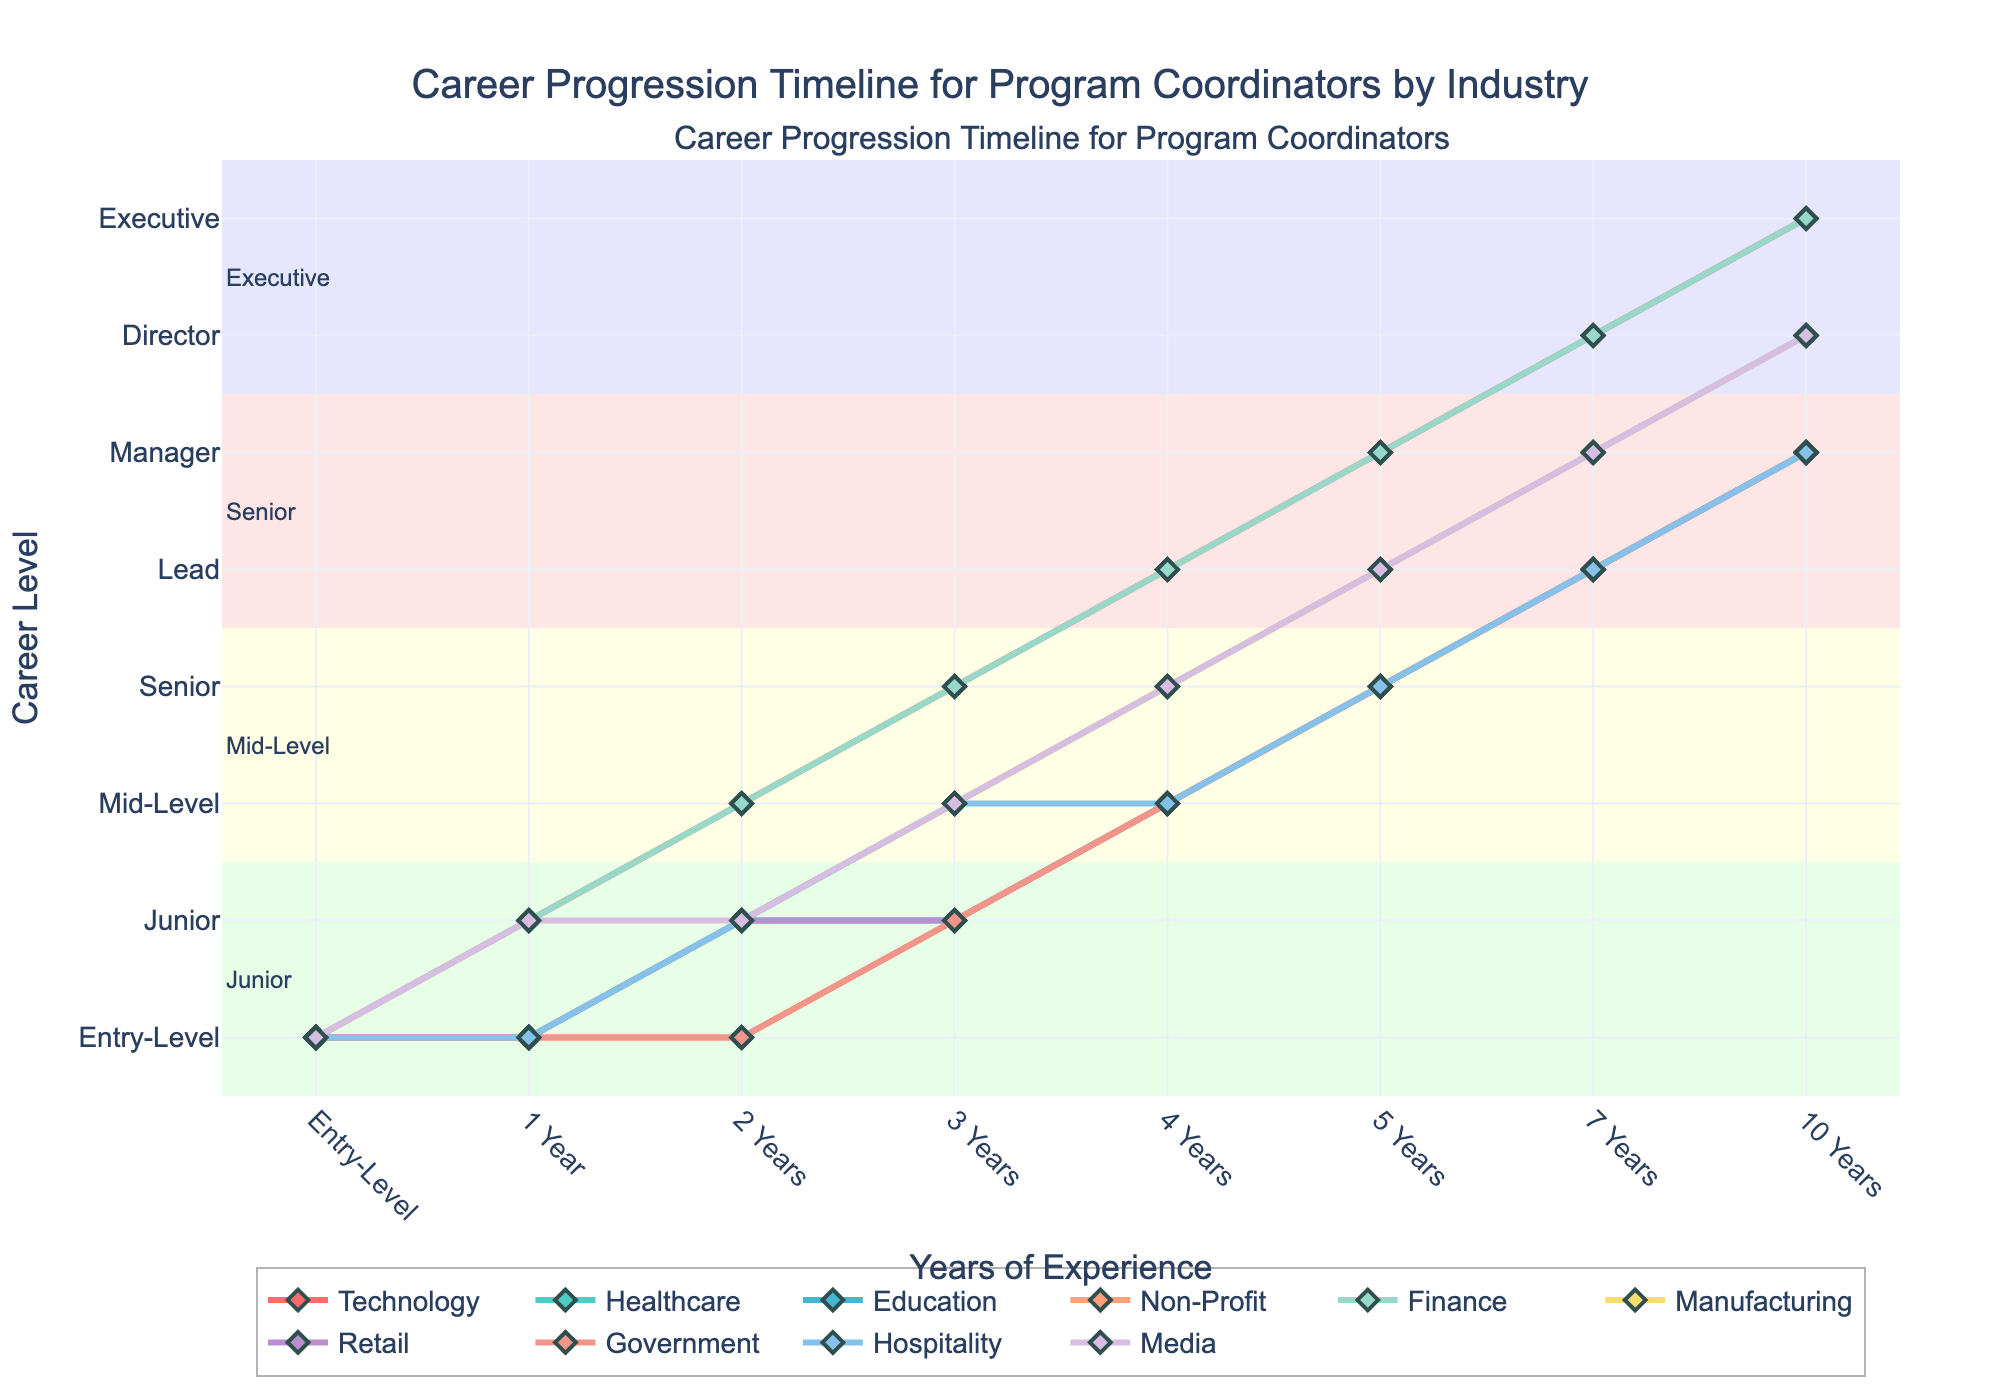What is the career level of a program coordinator in the Technology industry after 5 years? Look at the line representing the Technology industry and find the data point at the 5-year mark. The y-axis indicates the career level, which is 6, corresponding to 'Manager'.
Answer: Manager Which industry shows the fastest career progression in the first 2 years? Compare the slopes of the lines for different industries from 0 to 2 years. The Technology and Finance industries have the steepest slopes, both reaching level 3 in 2 years. Other industries reach lower career levels.
Answer: Technology, Finance After 4 years, which industry has the lowest career level for a program coordinator? Identify the 4-year mark across all lines and check the y-values. The Non-Profit, Education, and Government industries all reach level 3, which is the lowest at that time.
Answer: Non-Profit, Education, Government What is the average career level of a program coordinator in the Retail industry over the 10-year period? Sum up the career levels from 0 to 10 years for the Retail industry (1+1+2+2+3+4+5+6) = 24, then divide by the number of years (10) for the average (24/10).
Answer: 2.4 Compare the career progression of the Healthcare and Manufacturing industries from 1 year to 3 years. Which one progresses faster? Check the y-values at the 1-year to 3-year marks for both industries. Healthcare moves from level 1 to 3, while Manufacturing moves from level 1 to 3. Both progress at the same rate.
Answer: Same rate Which industry has the highest career level at the 7-year mark? Look at the 7-year mark across all lines and find the highest y-value. The Technology and Finance industries both reach level 7.
Answer: Technology, Finance From the 1-year mark to the 5-year mark, which industry has the slowest career progression? Analyze changes in career levels between 1 year and 5 years. Non-Profit moves from 1 to 4, which is relatively slow in comparison to other industries.
Answer: Non-Profit How does the career level of a Government program coordinator compare to a Media program coordinator at the 3-year mark? Find the y-values at the 3-year mark for Government and Media. Government is at level 2, while Media is at level 3. Thus, Media progresses higher.
Answer: Media progresses higher What is the median career level at the 4-year mark across all industries? List the career levels at the 4-year mark: [5, 4, 3, 3, 5, 4, 3, 3, 3, 4], sort them: [3, 3, 3, 3, 3, 4, 4, 4, 5, 5], and find the median value, which is 3.5.
Answer: 3.5 